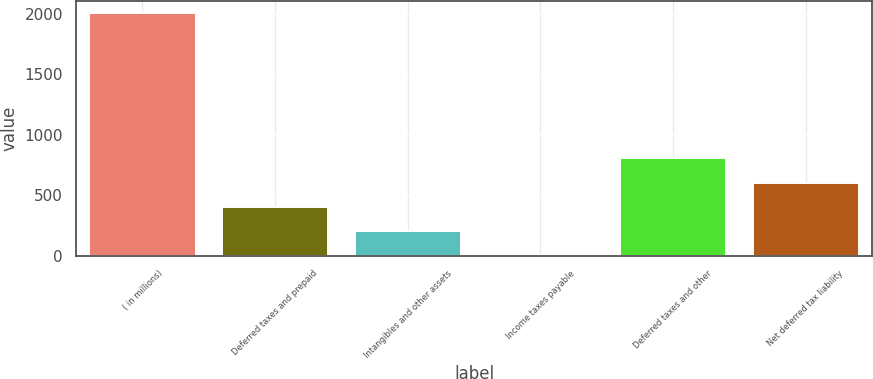Convert chart. <chart><loc_0><loc_0><loc_500><loc_500><bar_chart><fcel>( in millions)<fcel>Deferred taxes and prepaid<fcel>Intangibles and other assets<fcel>Income taxes payable<fcel>Deferred taxes and other<fcel>Net deferred tax liability<nl><fcel>2007<fcel>402.52<fcel>201.96<fcel>1.4<fcel>803.64<fcel>603.08<nl></chart> 